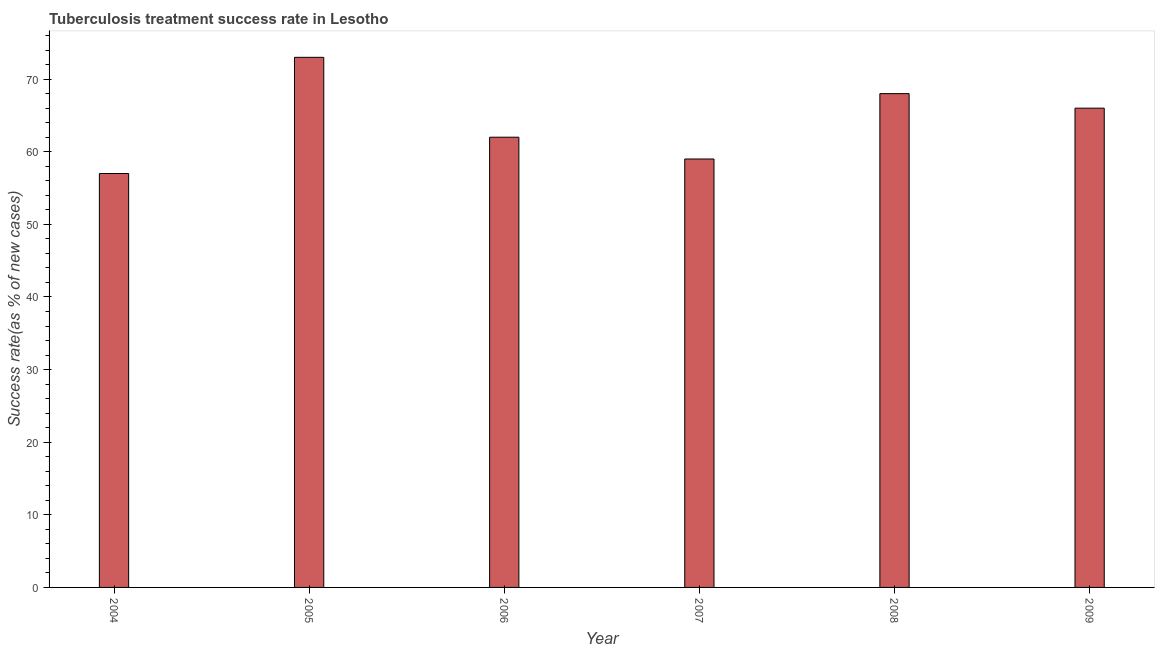Does the graph contain any zero values?
Give a very brief answer. No. Does the graph contain grids?
Provide a short and direct response. No. What is the title of the graph?
Provide a succinct answer. Tuberculosis treatment success rate in Lesotho. What is the label or title of the X-axis?
Your answer should be very brief. Year. What is the label or title of the Y-axis?
Your answer should be very brief. Success rate(as % of new cases). In which year was the tuberculosis treatment success rate maximum?
Ensure brevity in your answer.  2005. In which year was the tuberculosis treatment success rate minimum?
Provide a succinct answer. 2004. What is the sum of the tuberculosis treatment success rate?
Provide a succinct answer. 385. What is the average tuberculosis treatment success rate per year?
Your answer should be very brief. 64. In how many years, is the tuberculosis treatment success rate greater than 24 %?
Offer a very short reply. 6. What is the ratio of the tuberculosis treatment success rate in 2004 to that in 2005?
Provide a short and direct response. 0.78. Is the tuberculosis treatment success rate in 2005 less than that in 2009?
Provide a succinct answer. No. Is the difference between the tuberculosis treatment success rate in 2005 and 2009 greater than the difference between any two years?
Make the answer very short. No. In how many years, is the tuberculosis treatment success rate greater than the average tuberculosis treatment success rate taken over all years?
Provide a succinct answer. 3. How many bars are there?
Ensure brevity in your answer.  6. Are all the bars in the graph horizontal?
Ensure brevity in your answer.  No. How many years are there in the graph?
Your answer should be very brief. 6. What is the difference between two consecutive major ticks on the Y-axis?
Make the answer very short. 10. Are the values on the major ticks of Y-axis written in scientific E-notation?
Your response must be concise. No. What is the Success rate(as % of new cases) in 2004?
Your answer should be very brief. 57. What is the Success rate(as % of new cases) of 2005?
Offer a terse response. 73. What is the Success rate(as % of new cases) of 2006?
Provide a short and direct response. 62. What is the Success rate(as % of new cases) of 2007?
Offer a terse response. 59. What is the Success rate(as % of new cases) in 2008?
Keep it short and to the point. 68. What is the Success rate(as % of new cases) in 2009?
Give a very brief answer. 66. What is the difference between the Success rate(as % of new cases) in 2004 and 2005?
Give a very brief answer. -16. What is the difference between the Success rate(as % of new cases) in 2004 and 2006?
Offer a terse response. -5. What is the difference between the Success rate(as % of new cases) in 2004 and 2007?
Your answer should be very brief. -2. What is the difference between the Success rate(as % of new cases) in 2004 and 2008?
Give a very brief answer. -11. What is the difference between the Success rate(as % of new cases) in 2005 and 2008?
Your answer should be compact. 5. What is the difference between the Success rate(as % of new cases) in 2005 and 2009?
Your answer should be very brief. 7. What is the difference between the Success rate(as % of new cases) in 2006 and 2007?
Offer a terse response. 3. What is the difference between the Success rate(as % of new cases) in 2008 and 2009?
Make the answer very short. 2. What is the ratio of the Success rate(as % of new cases) in 2004 to that in 2005?
Ensure brevity in your answer.  0.78. What is the ratio of the Success rate(as % of new cases) in 2004 to that in 2006?
Offer a very short reply. 0.92. What is the ratio of the Success rate(as % of new cases) in 2004 to that in 2008?
Make the answer very short. 0.84. What is the ratio of the Success rate(as % of new cases) in 2004 to that in 2009?
Offer a very short reply. 0.86. What is the ratio of the Success rate(as % of new cases) in 2005 to that in 2006?
Your answer should be compact. 1.18. What is the ratio of the Success rate(as % of new cases) in 2005 to that in 2007?
Provide a short and direct response. 1.24. What is the ratio of the Success rate(as % of new cases) in 2005 to that in 2008?
Offer a very short reply. 1.07. What is the ratio of the Success rate(as % of new cases) in 2005 to that in 2009?
Your answer should be very brief. 1.11. What is the ratio of the Success rate(as % of new cases) in 2006 to that in 2007?
Ensure brevity in your answer.  1.05. What is the ratio of the Success rate(as % of new cases) in 2006 to that in 2008?
Ensure brevity in your answer.  0.91. What is the ratio of the Success rate(as % of new cases) in 2006 to that in 2009?
Offer a terse response. 0.94. What is the ratio of the Success rate(as % of new cases) in 2007 to that in 2008?
Your response must be concise. 0.87. What is the ratio of the Success rate(as % of new cases) in 2007 to that in 2009?
Provide a succinct answer. 0.89. 